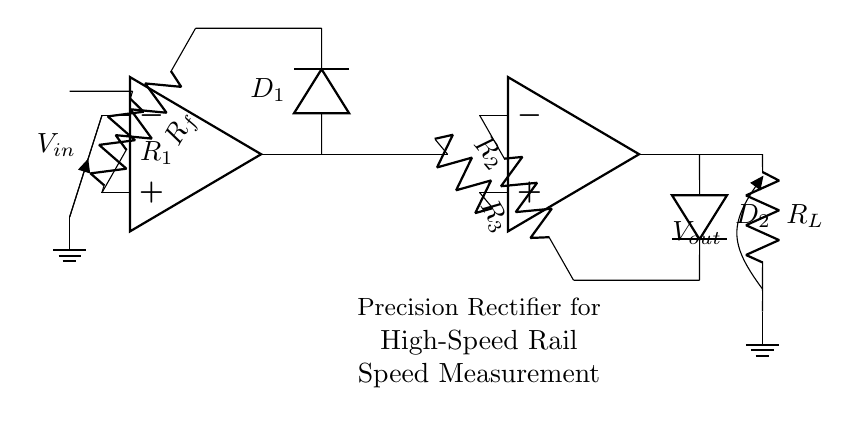What is the input voltage denoted in the circuit? The input voltage is labeled as V_in in the circuit diagram. This is identified at the negative terminal of the first operational amplifier.
Answer: V_in What are the values of the resistors R_1, R_2, and R_3? The circuit diagram shows R_1, R_2, and R_3, but does not specify their numerical values directly. They are just labeled as R_1, R_2, and R_3.
Answer: Not specified Which component is responsible for the precision rectification? The precision rectification is performed by the two operational amplifiers and their respective diodes, D_1 and D_2. The circuit is designed specifically to rectify the input voltage more accurately than a standard rectifier.
Answer: Operational amplifiers and D_1, D_2 How many operational amplifiers are used in the circuit? There are two operational amplifiers present in the circuit design, as denoted by the symbols drawn at the left and right section of the circuit.
Answer: 2 What is the output voltage labeled in the circuit? The output voltage is labeled as V_out, indicated at the output of the second operational amplifier and connected to R_L.
Answer: V_out What role do the diodes D_1 and D_2 play in this circuit? The diodes D_1 and D_2 are used to allow current to flow in one direction only, enabling the function of precision rectification by preventing negative voltage readings from affecting the output.
Answer: Precision rectification 